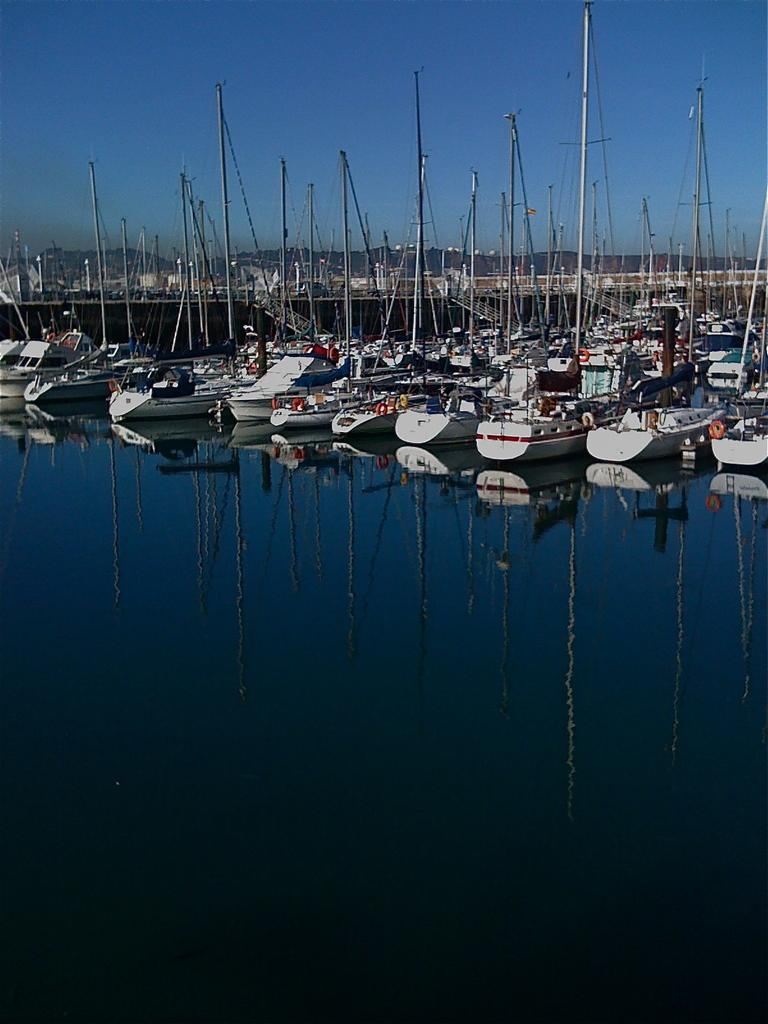What is the main subject of the image? The main subject of the image is a group of boats. Where are the boats located? The boats are on water. What else can be seen in the image besides the boats? There are poles in the image. What is visible in the background of the image? The sky is visible in the background of the image. What type of copper beast can be seen in the garden in the image? There is no copper beast or garden present in the image; it features a group of boats on water with poles and a visible sky in the background. 